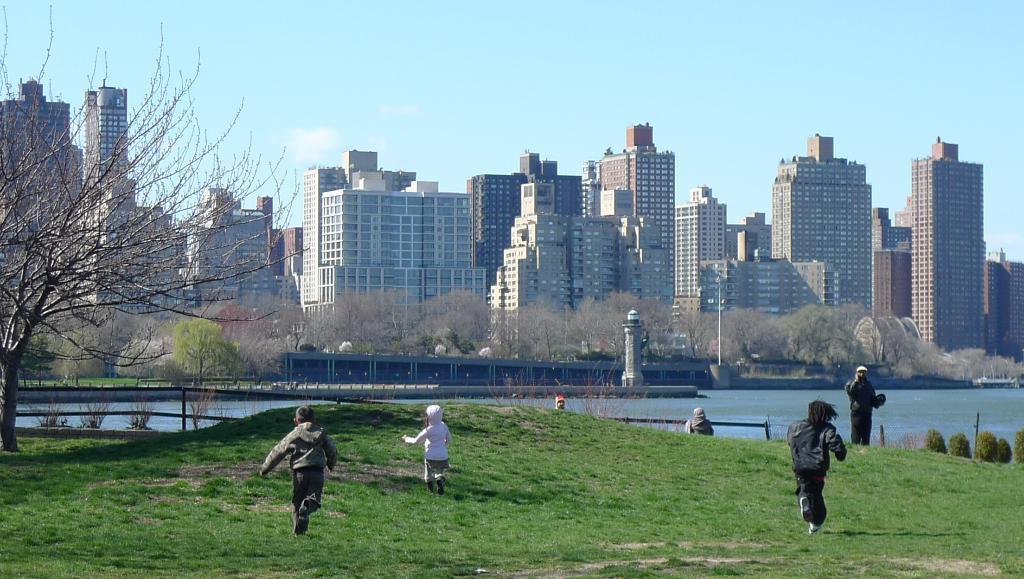Could you give a brief overview of what you see in this image? This picture is taken outside. At the bottom there is grass. On the grass, there are kids running towards the north. Towards the left, there is a tree. Beside the grass, there is water. On the top, there are building, trees etc. In the background, there is a sky with clouds. 